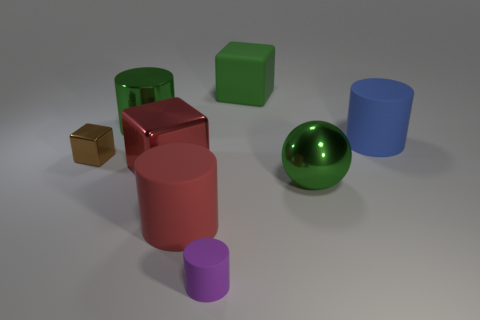What is the shape of the tiny matte thing?
Make the answer very short. Cylinder. What number of gray blocks are the same material as the purple thing?
Your answer should be compact. 0. There is a tiny cylinder; is its color the same as the matte cylinder that is behind the large red rubber thing?
Offer a very short reply. No. What number of tiny metal spheres are there?
Your answer should be compact. 0. Is there a large shiny cylinder that has the same color as the matte cube?
Offer a very short reply. Yes. What is the color of the metal ball on the right side of the red object in front of the shiny object on the right side of the big matte cube?
Make the answer very short. Green. Is the big blue object made of the same material as the cylinder left of the red metal cube?
Your answer should be compact. No. What is the red cube made of?
Keep it short and to the point. Metal. There is a sphere that is the same color as the rubber block; what is it made of?
Your response must be concise. Metal. How many other objects are there of the same material as the tiny purple object?
Offer a very short reply. 3. 